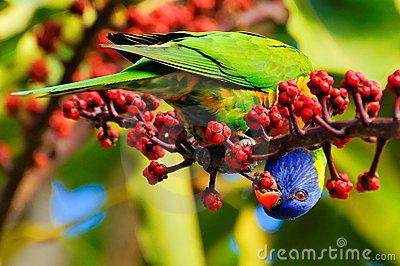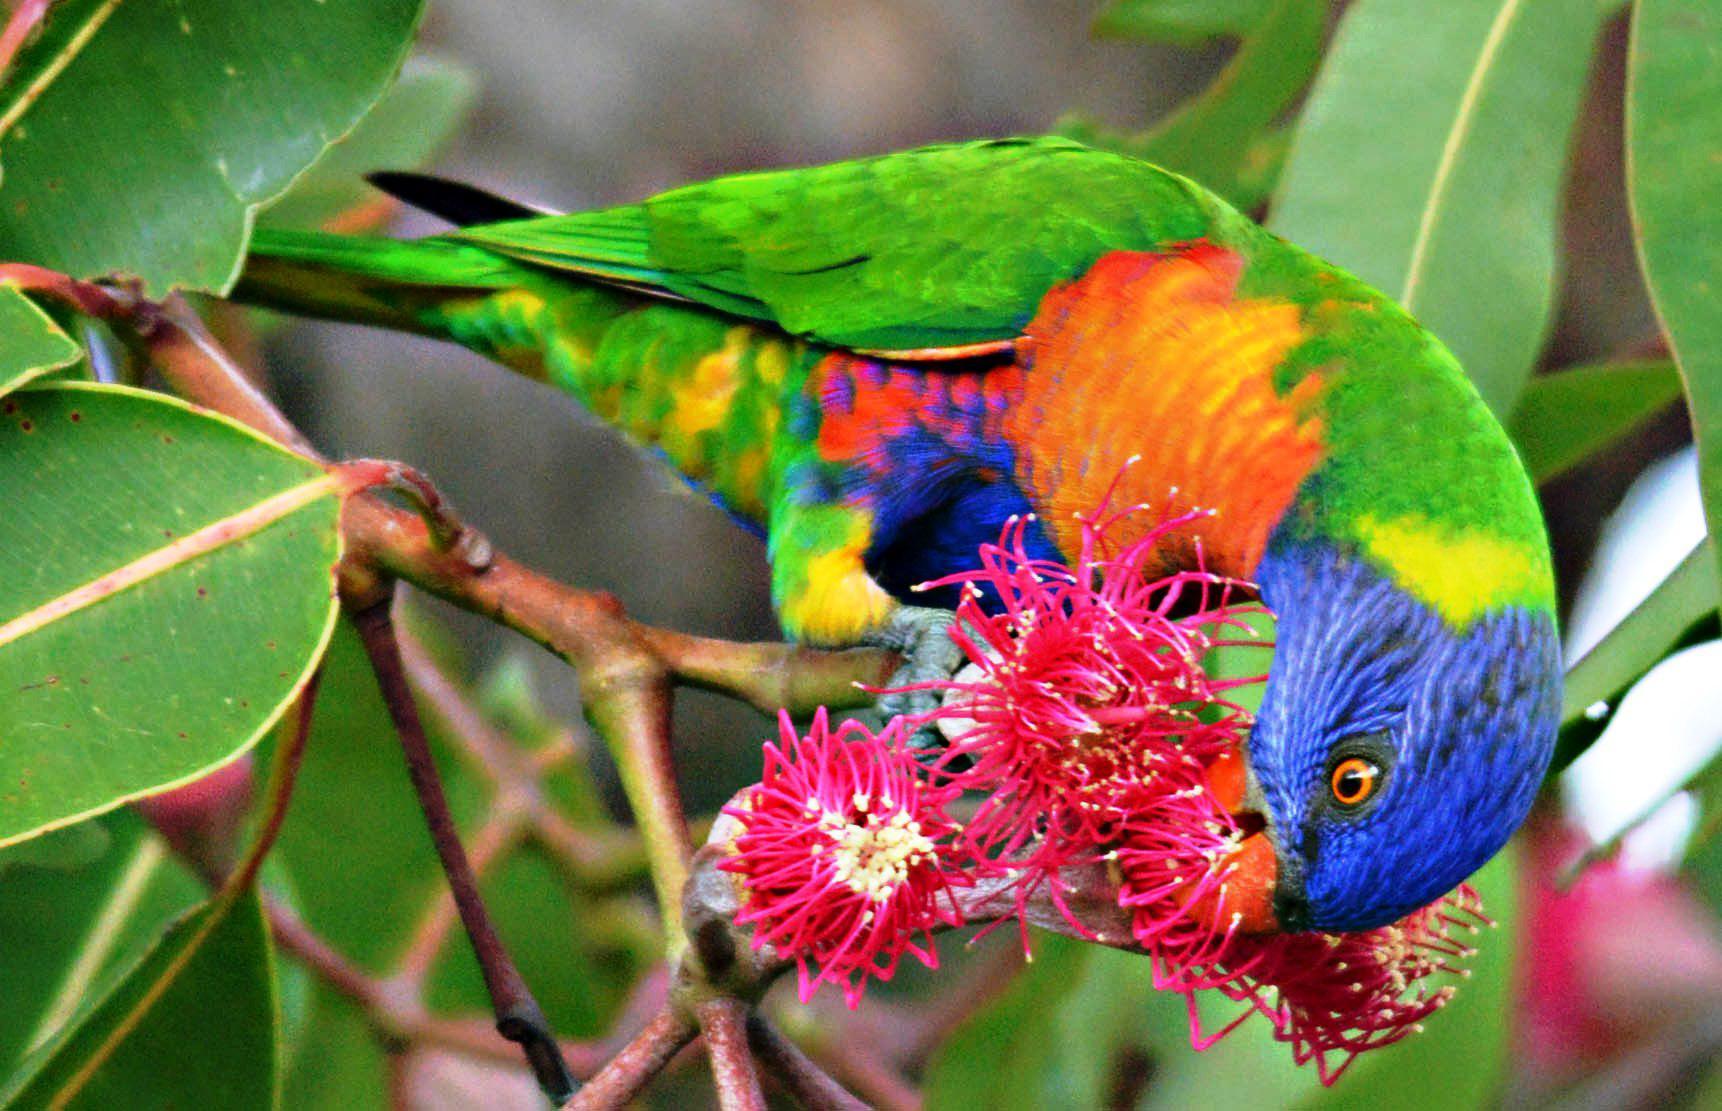The first image is the image on the left, the second image is the image on the right. Given the left and right images, does the statement "In both image the rainbow lorikeet is eating." hold true? Answer yes or no. Yes. The first image is the image on the left, the second image is the image on the right. Analyze the images presented: Is the assertion "There are at least four birds in total." valid? Answer yes or no. No. 